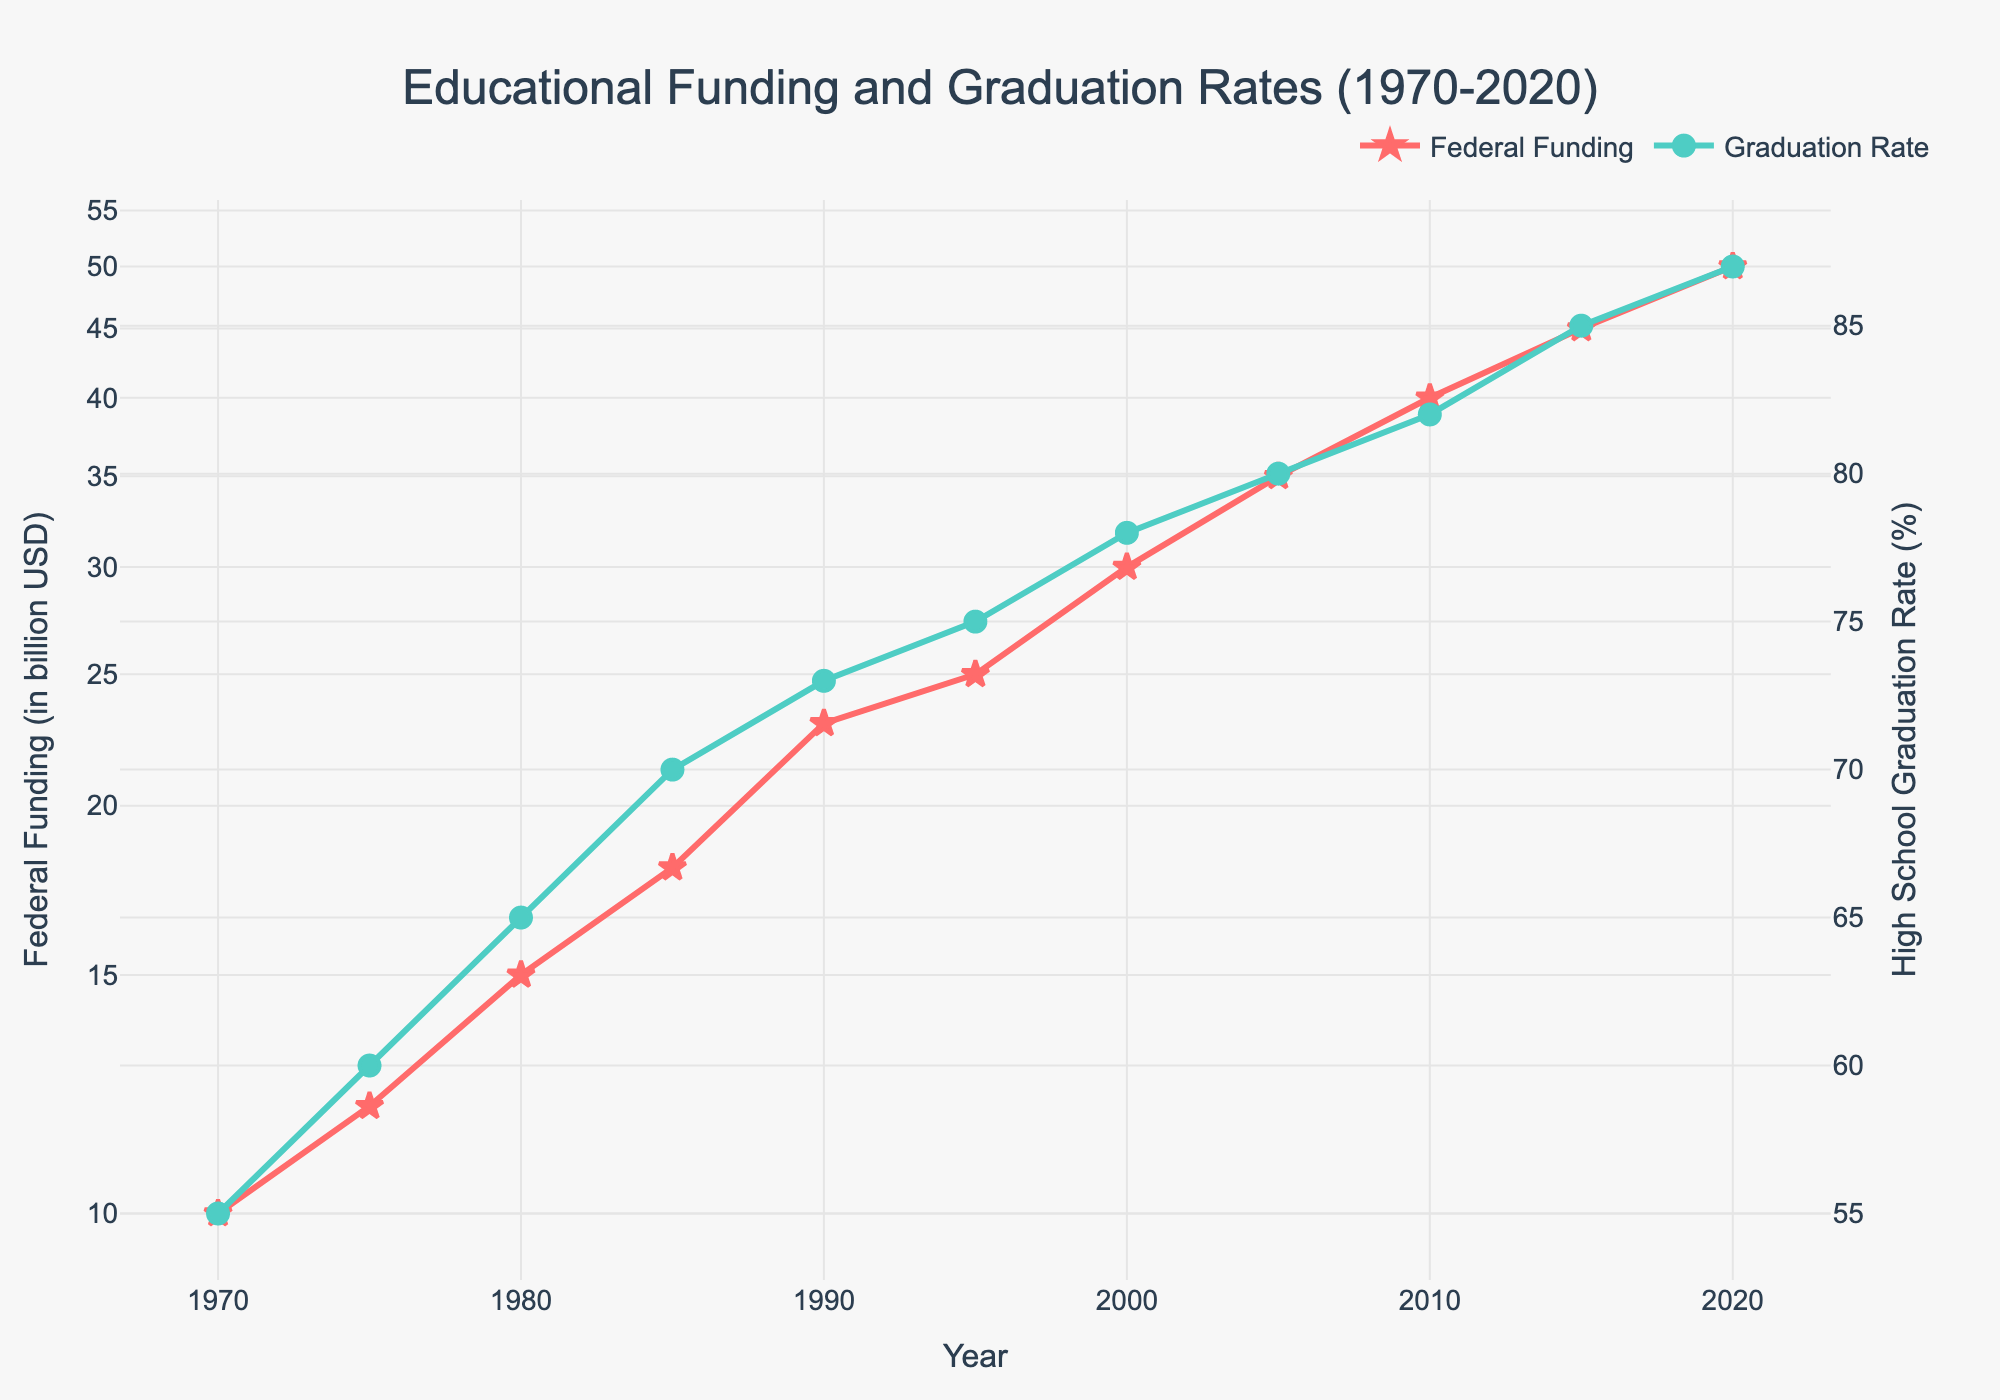What is the title of the plot? Look at the top of the figure where the main title is located. The title reads "Educational Funding and Graduation Rates (1970-2020)".
Answer: Educational Funding and Graduation Rates (1970-2020) What color represents Federal Funding, and what color represents High School Graduation Rate on the plot? Observe the color of the lines and markers for each labeled trace in the legend. Federal Funding is marked with red while Graduation Rate is marked with green.
Answer: Red for Federal Funding and Green for Graduation Rate How did the Federal Funding trend over the last 50 years? Examine the red line on the plot representing Federal Funding. It shows a consistent increase from 10 billion USD in 1970 to 50 billion USD in 2020.
Answer: Consistent increase Which year had the sharpest increase in Federal Funding? Look for the year where the slope of the red line (Federal Funding) is steepest. The steepest increase is noted between 1980 (15 billion USD) and 1990 (23 billion USD).
Answer: Between 1980 and 1990 How much did the High School Graduation Rate change from 1970 to 2020? Identify the Graduation Rates at the starting (1970) and ending points (2020). In 1970, the rate was 55%, and in 2020, it was 87%. Calculate the difference: 87% - 55% = 32%.
Answer: 32% What is the difference in Federal Funding between 1995 and 2005? Determine the Federal Funding values for 1995 and 2005 (25 billion USD and 35 billion USD, respectively) and calculate the difference: 35 - 25 = 10 billion USD.
Answer: 10 billion USD Which variable shows a log scale on its axis? Observe the configuration of the y-axes. The y-axis for Federal Funding is in a log scale as indicated by the tick marks and format of numbers.
Answer: Federal Funding By how much did the High School Graduation Rate increase between 1985 and 2000? Check the Graduation Rates at 1985 (70%) and 2000 (78%) and calculate the difference: 78% - 70% = 8%.
Answer: 8% What relationship can be inferred between Federal Funding and Graduation Rates over the period? Both trends show an increase, suggesting a possible positive relationship between increased Federal Funding and higher High School Graduation Rates.
Answer: Positive relationship During what period did the High School Graduation Rate see the least increase? Identify periods with minimal slope change for the green line (Graduation Rate). The smallest increase is observed between 2010 (82%) and 2015 (85%), showing only a 3% increase.
Answer: Between 2010 and 2015 